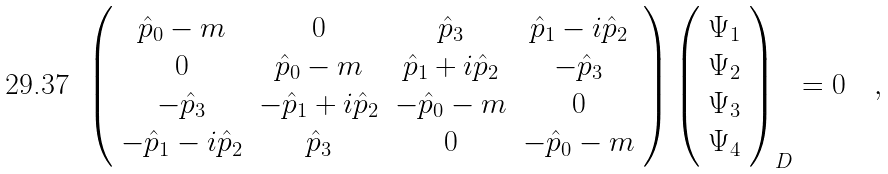Convert formula to latex. <formula><loc_0><loc_0><loc_500><loc_500>\left ( \begin{array} { c c c c } { { \hat { p } _ { 0 } - m } } & { 0 } & { { \hat { p } _ { 3 } } } & { { \hat { p } _ { 1 } - i \hat { p } _ { 2 } } } \\ { 0 } & { { \hat { p } _ { 0 } - m } } & { { \hat { p } _ { 1 } + i \hat { p } _ { 2 } } } & { { - \hat { p } _ { 3 } } } \\ { { - \hat { p } _ { 3 } } } & { { - \hat { p } _ { 1 } + i \hat { p } _ { 2 } } } & { { - \hat { p } _ { 0 } - m } } & { 0 } \\ { { - \hat { p } _ { 1 } - i \hat { p } _ { 2 } } } & { { \hat { p } _ { 3 } } } & { 0 } & { { - \hat { p } _ { 0 } - m } } \end{array} \right ) \left ( \begin{array} { c c c c } { { \Psi _ { 1 } } } \\ { { \Psi _ { 2 } } } \\ { { \Psi _ { 3 } } } \\ { { \Psi _ { 4 } } } \end{array} \right ) _ { D } = 0 \quad ,</formula> 